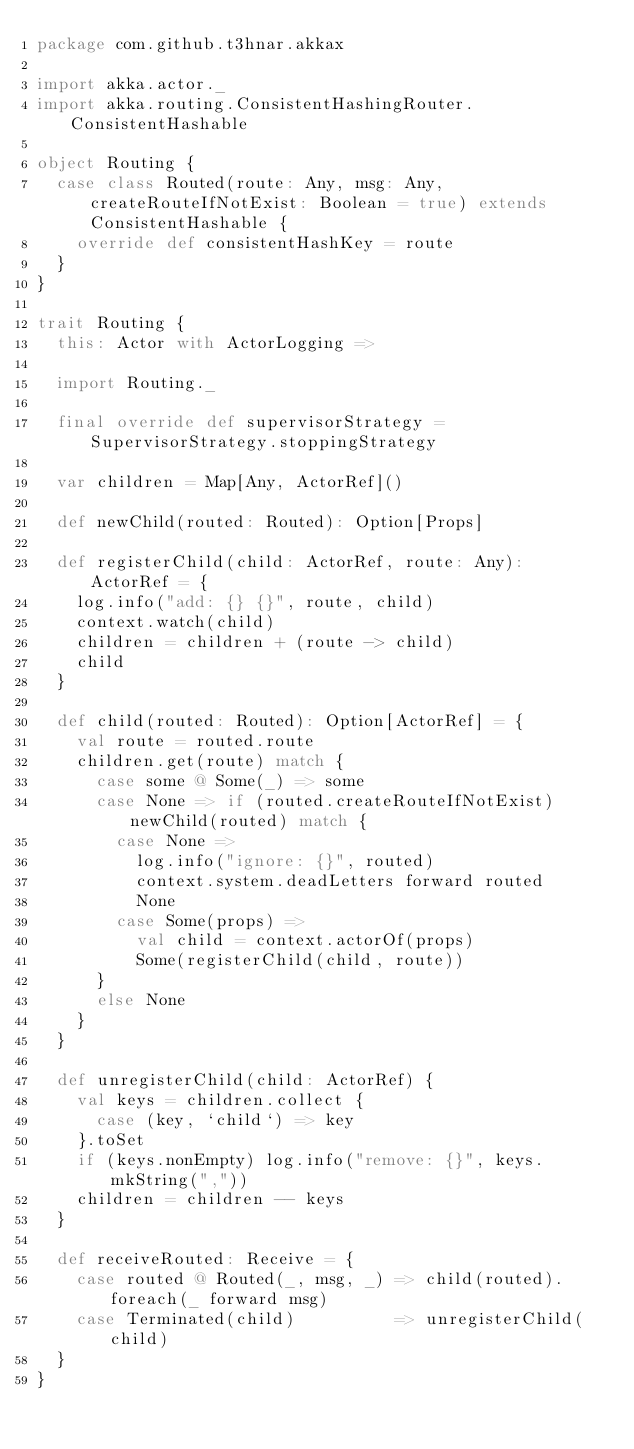<code> <loc_0><loc_0><loc_500><loc_500><_Scala_>package com.github.t3hnar.akkax

import akka.actor._
import akka.routing.ConsistentHashingRouter.ConsistentHashable

object Routing {
  case class Routed(route: Any, msg: Any, createRouteIfNotExist: Boolean = true) extends ConsistentHashable {
    override def consistentHashKey = route
  }
}

trait Routing {
  this: Actor with ActorLogging =>

  import Routing._

  final override def supervisorStrategy = SupervisorStrategy.stoppingStrategy

  var children = Map[Any, ActorRef]()

  def newChild(routed: Routed): Option[Props]

  def registerChild(child: ActorRef, route: Any): ActorRef = {
    log.info("add: {} {}", route, child)
    context.watch(child)
    children = children + (route -> child)
    child
  }

  def child(routed: Routed): Option[ActorRef] = {
    val route = routed.route
    children.get(route) match {
      case some @ Some(_) => some
      case None => if (routed.createRouteIfNotExist) newChild(routed) match {
        case None =>
          log.info("ignore: {}", routed)
          context.system.deadLetters forward routed
          None
        case Some(props) =>
          val child = context.actorOf(props)
          Some(registerChild(child, route))
      }
      else None
    }
  }

  def unregisterChild(child: ActorRef) {
    val keys = children.collect {
      case (key, `child`) => key
    }.toSet
    if (keys.nonEmpty) log.info("remove: {}", keys.mkString(","))
    children = children -- keys
  }

  def receiveRouted: Receive = {
    case routed @ Routed(_, msg, _) => child(routed).foreach(_ forward msg)
    case Terminated(child)          => unregisterChild(child)
  }
}</code> 